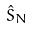<formula> <loc_0><loc_0><loc_500><loc_500>\hat { S } _ { N }</formula> 